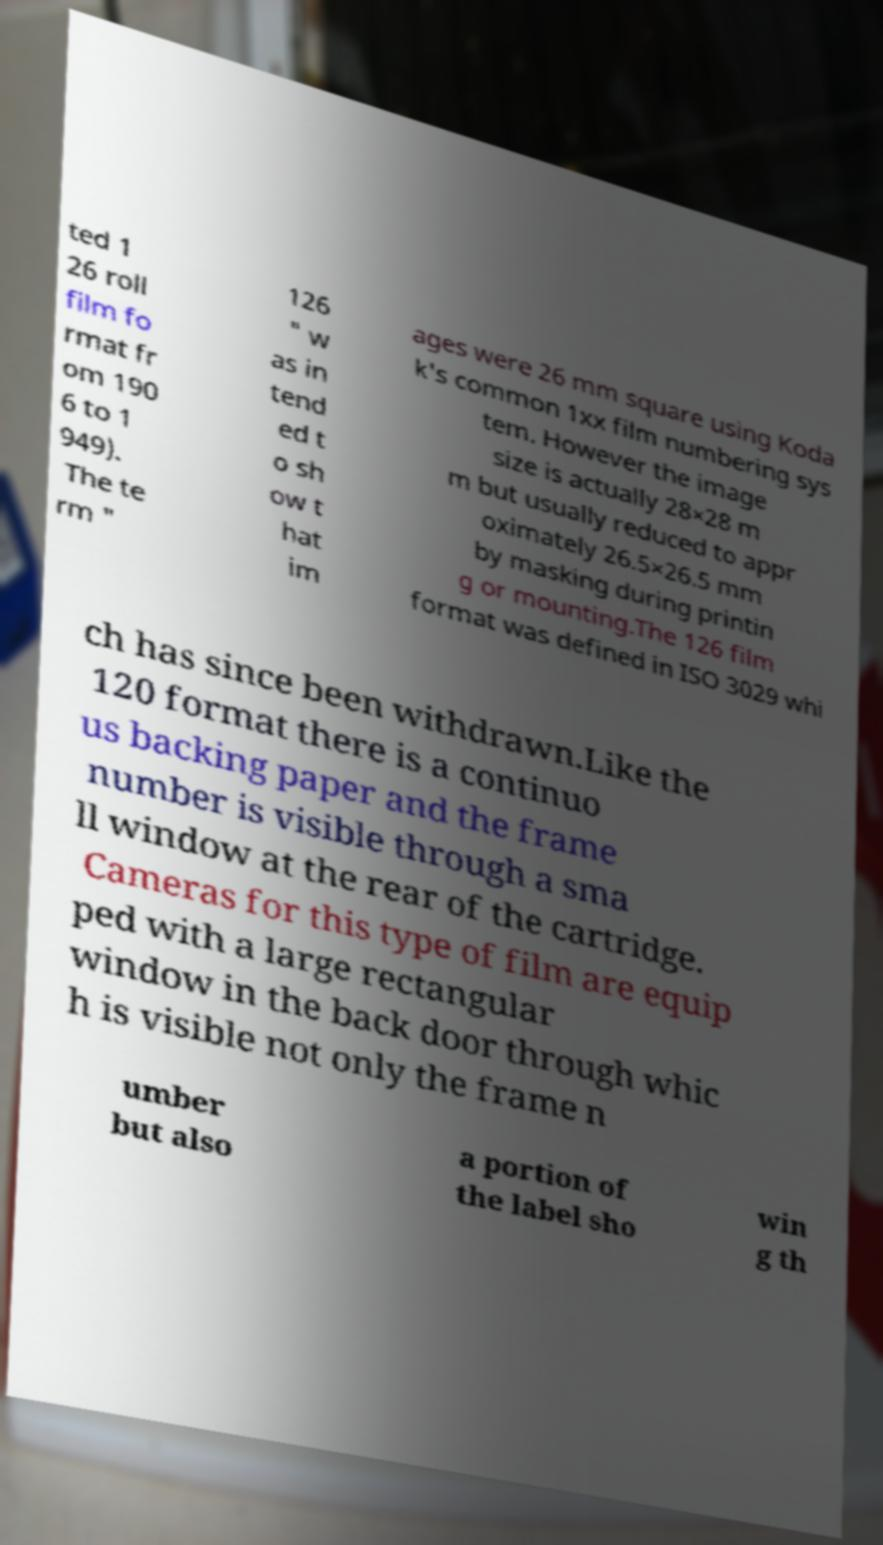Could you extract and type out the text from this image? ted 1 26 roll film fo rmat fr om 190 6 to 1 949). The te rm " 126 " w as in tend ed t o sh ow t hat im ages were 26 mm square using Koda k's common 1xx film numbering sys tem. However the image size is actually 28×28 m m but usually reduced to appr oximately 26.5×26.5 mm by masking during printin g or mounting.The 126 film format was defined in ISO 3029 whi ch has since been withdrawn.Like the 120 format there is a continuo us backing paper and the frame number is visible through a sma ll window at the rear of the cartridge. Cameras for this type of film are equip ped with a large rectangular window in the back door through whic h is visible not only the frame n umber but also a portion of the label sho win g th 